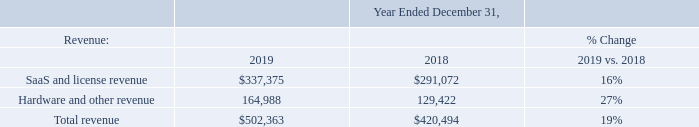Comparison of Years Ended December 31, 2019 to December 31, 2018
The following tables in this section set forth our selected consolidated statements of operations (in thousands), data for the percentage change and data as a percentage of revenue for the years ended December 31, 2019 and 2018. Certain previously reported amounts in the consolidated statements of operations for the year ended December 31, 2018 have been reclassified to conform to our current presentation to reflect interest income as a separate line item, which was previously included in other income, net.
Revenue
The $81.9 million increase in total revenue in 2019 as compared to 2018 was the result of a $46.3 million, or 16%, increase in our SaaS and license revenue and a $35.6 million, or 27%, increase in our hardware and other revenue. Our software license revenue included within SaaS and license revenue increased $2.1 million to $43.4 million in 2019 as compared to $41.3 million during 2018. The increase in our Alarm.com segment SaaS and license revenue in 2019 was primarily due to growth in our subscriber base, including the revenue impact from subscribers we added in 2018. To a lesser extent, SaaS and license revenue increased in the period due to an increase in license fees. The increase in hardware and other revenue in 2019 compared to 2018 was due to an increase in the volume of video cameras sold. Our Other segment contributed 15% of the increase in SaaS and license revenue in 2019 as compared to 2018. The increase in SaaS and license revenue for our Other segment in 2019 as compared to 2018 was due to an increase in sales of our energy management and demand response solutions and our property management and HVAC solutions. Hardware and other revenue in our Other segment decreased 13% in 2019 as compared to 2018, primarily due to the timing of sales related to our remote access management solution.
What was the increase in the company's Alarm.com segment SaaS and license revenue in 2019 was primarily due to? Growth in our subscriber base, including the revenue impact from subscribers we added in 2018. Why was there an increase in hardware and other revenue in 2019 compared to 2018? Due to an increase in the volume of video cameras sold. What was the SaaS and license revenue in 2019?
Answer scale should be: thousand. $337,375. How many years did SaaS and license revenue exceed $300,000 thousand? 2019
Answer: 1. How many components of revenue exceeded $200,000 thousand in 2018? SaaS and license revenue
Answer: 1. What was SaaS and license revenue as a percentage of total revenue in 2019?
Answer scale should be: percent. 337,375/502,363
Answer: 67.16. 